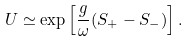<formula> <loc_0><loc_0><loc_500><loc_500>U \simeq \exp \left [ \frac { g } { \omega } ( S _ { + } - S _ { - } ) \right ] .</formula> 